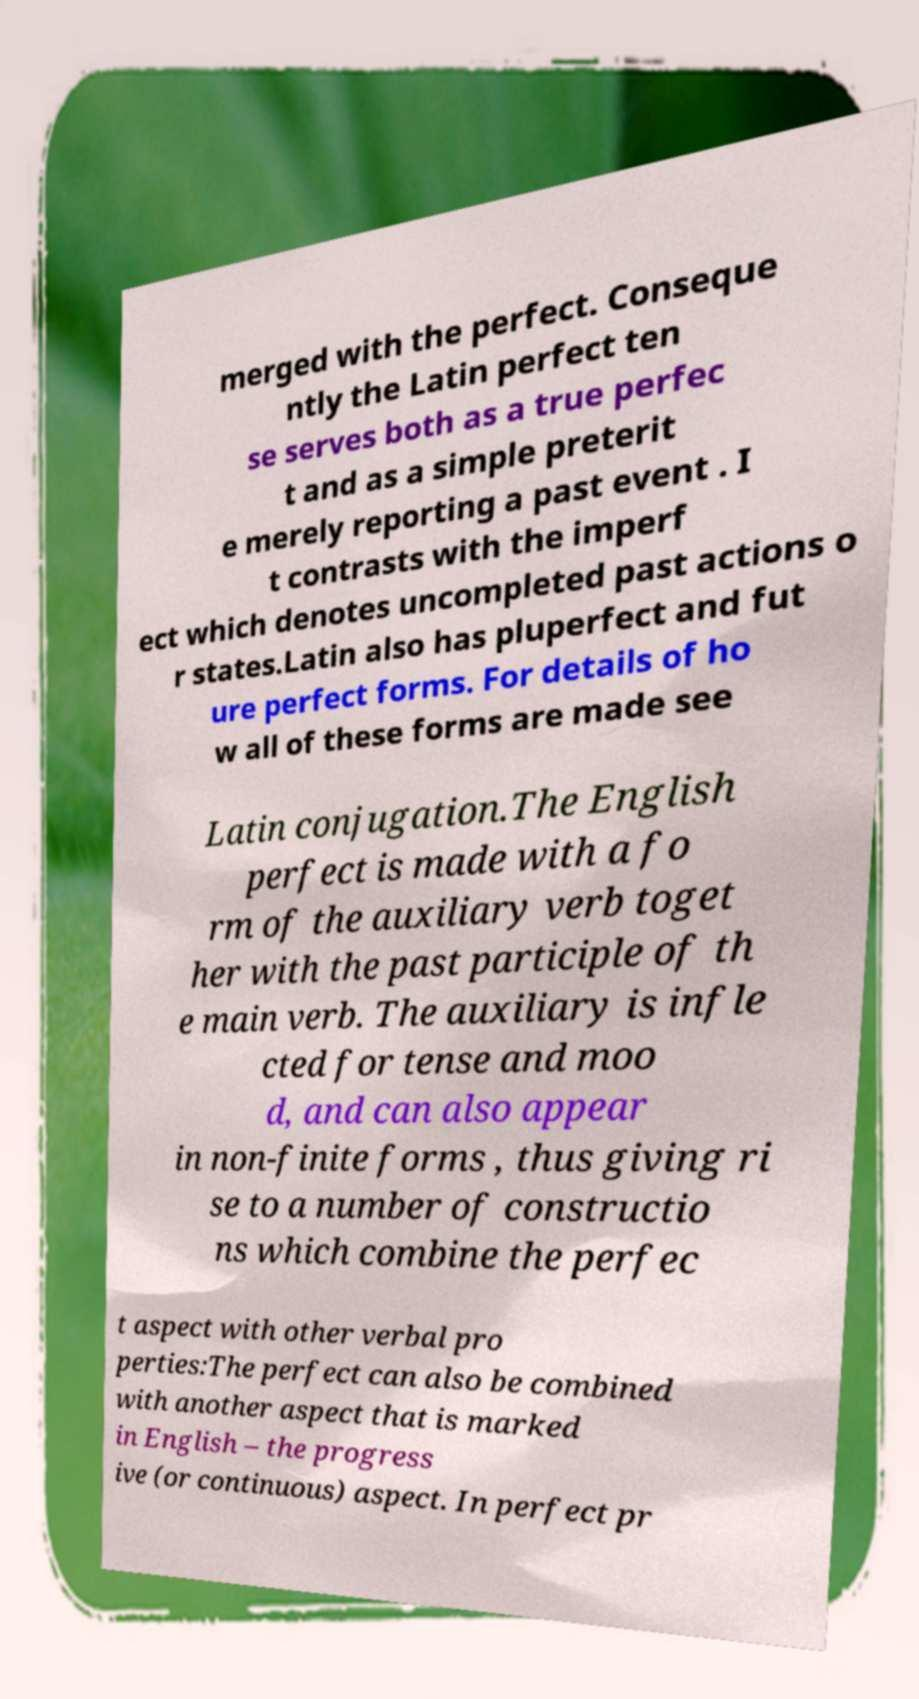For documentation purposes, I need the text within this image transcribed. Could you provide that? merged with the perfect. Conseque ntly the Latin perfect ten se serves both as a true perfec t and as a simple preterit e merely reporting a past event . I t contrasts with the imperf ect which denotes uncompleted past actions o r states.Latin also has pluperfect and fut ure perfect forms. For details of ho w all of these forms are made see Latin conjugation.The English perfect is made with a fo rm of the auxiliary verb toget her with the past participle of th e main verb. The auxiliary is infle cted for tense and moo d, and can also appear in non-finite forms , thus giving ri se to a number of constructio ns which combine the perfec t aspect with other verbal pro perties:The perfect can also be combined with another aspect that is marked in English – the progress ive (or continuous) aspect. In perfect pr 